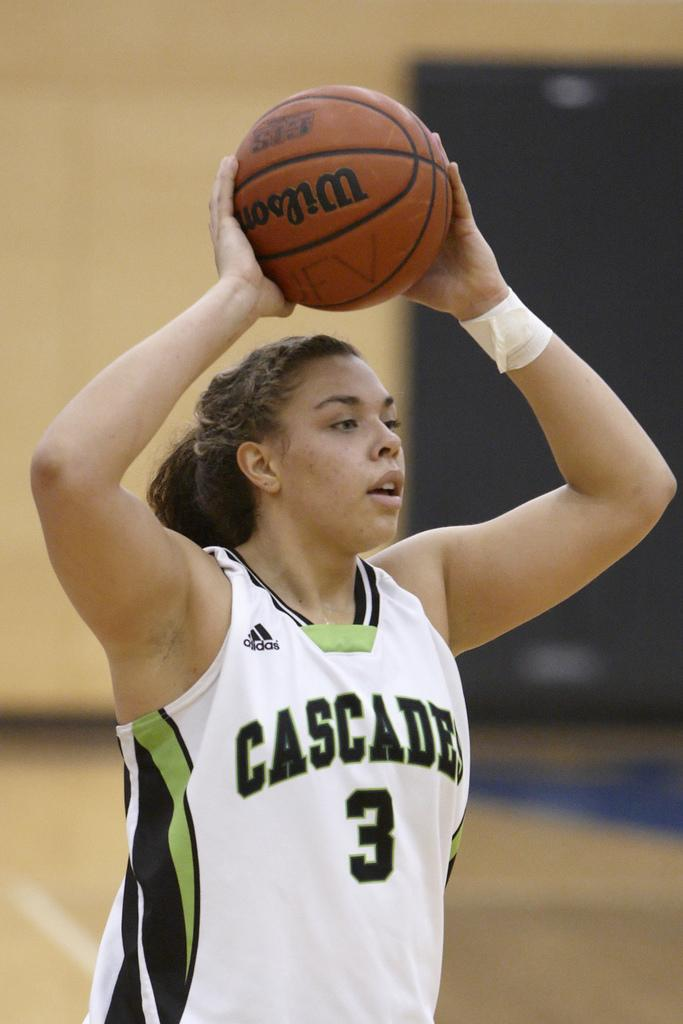<image>
Render a clear and concise summary of the photo. A female cascades's player holds a basketball over her head. 